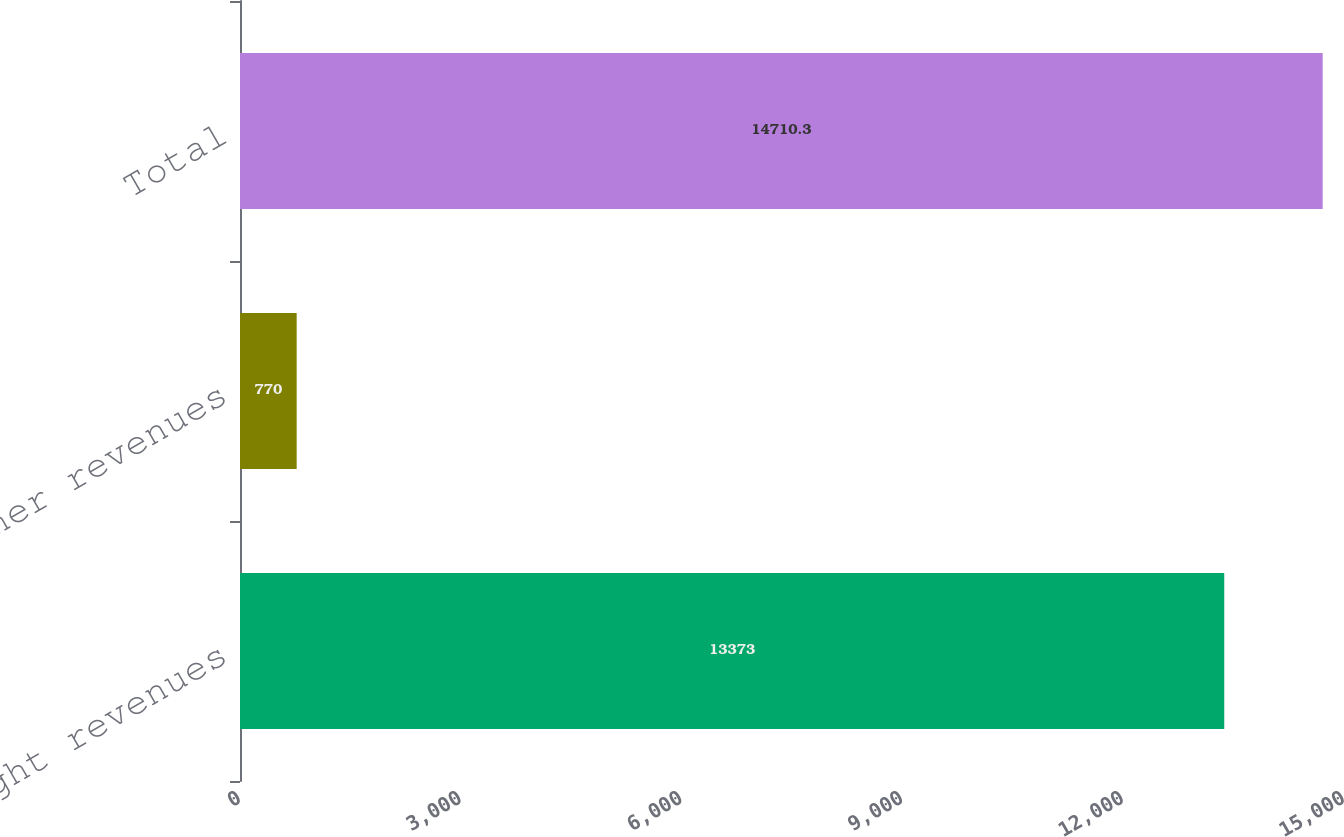Convert chart. <chart><loc_0><loc_0><loc_500><loc_500><bar_chart><fcel>Freight revenues<fcel>Other revenues<fcel>Total<nl><fcel>13373<fcel>770<fcel>14710.3<nl></chart> 